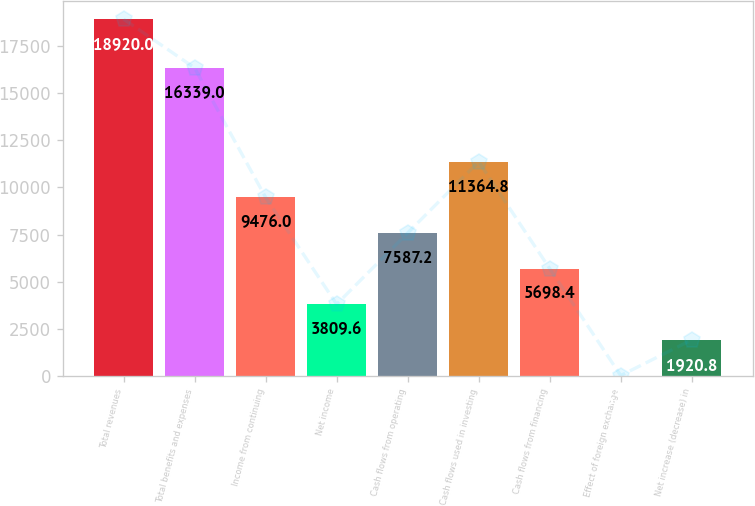<chart> <loc_0><loc_0><loc_500><loc_500><bar_chart><fcel>Total revenues<fcel>Total benefits and expenses<fcel>Income from continuing<fcel>Net income<fcel>Cash flows from operating<fcel>Cash flows used in investing<fcel>Cash flows from financing<fcel>Effect of foreign exchange<fcel>Net increase (decrease) in<nl><fcel>18920<fcel>16339<fcel>9476<fcel>3809.6<fcel>7587.2<fcel>11364.8<fcel>5698.4<fcel>32<fcel>1920.8<nl></chart> 